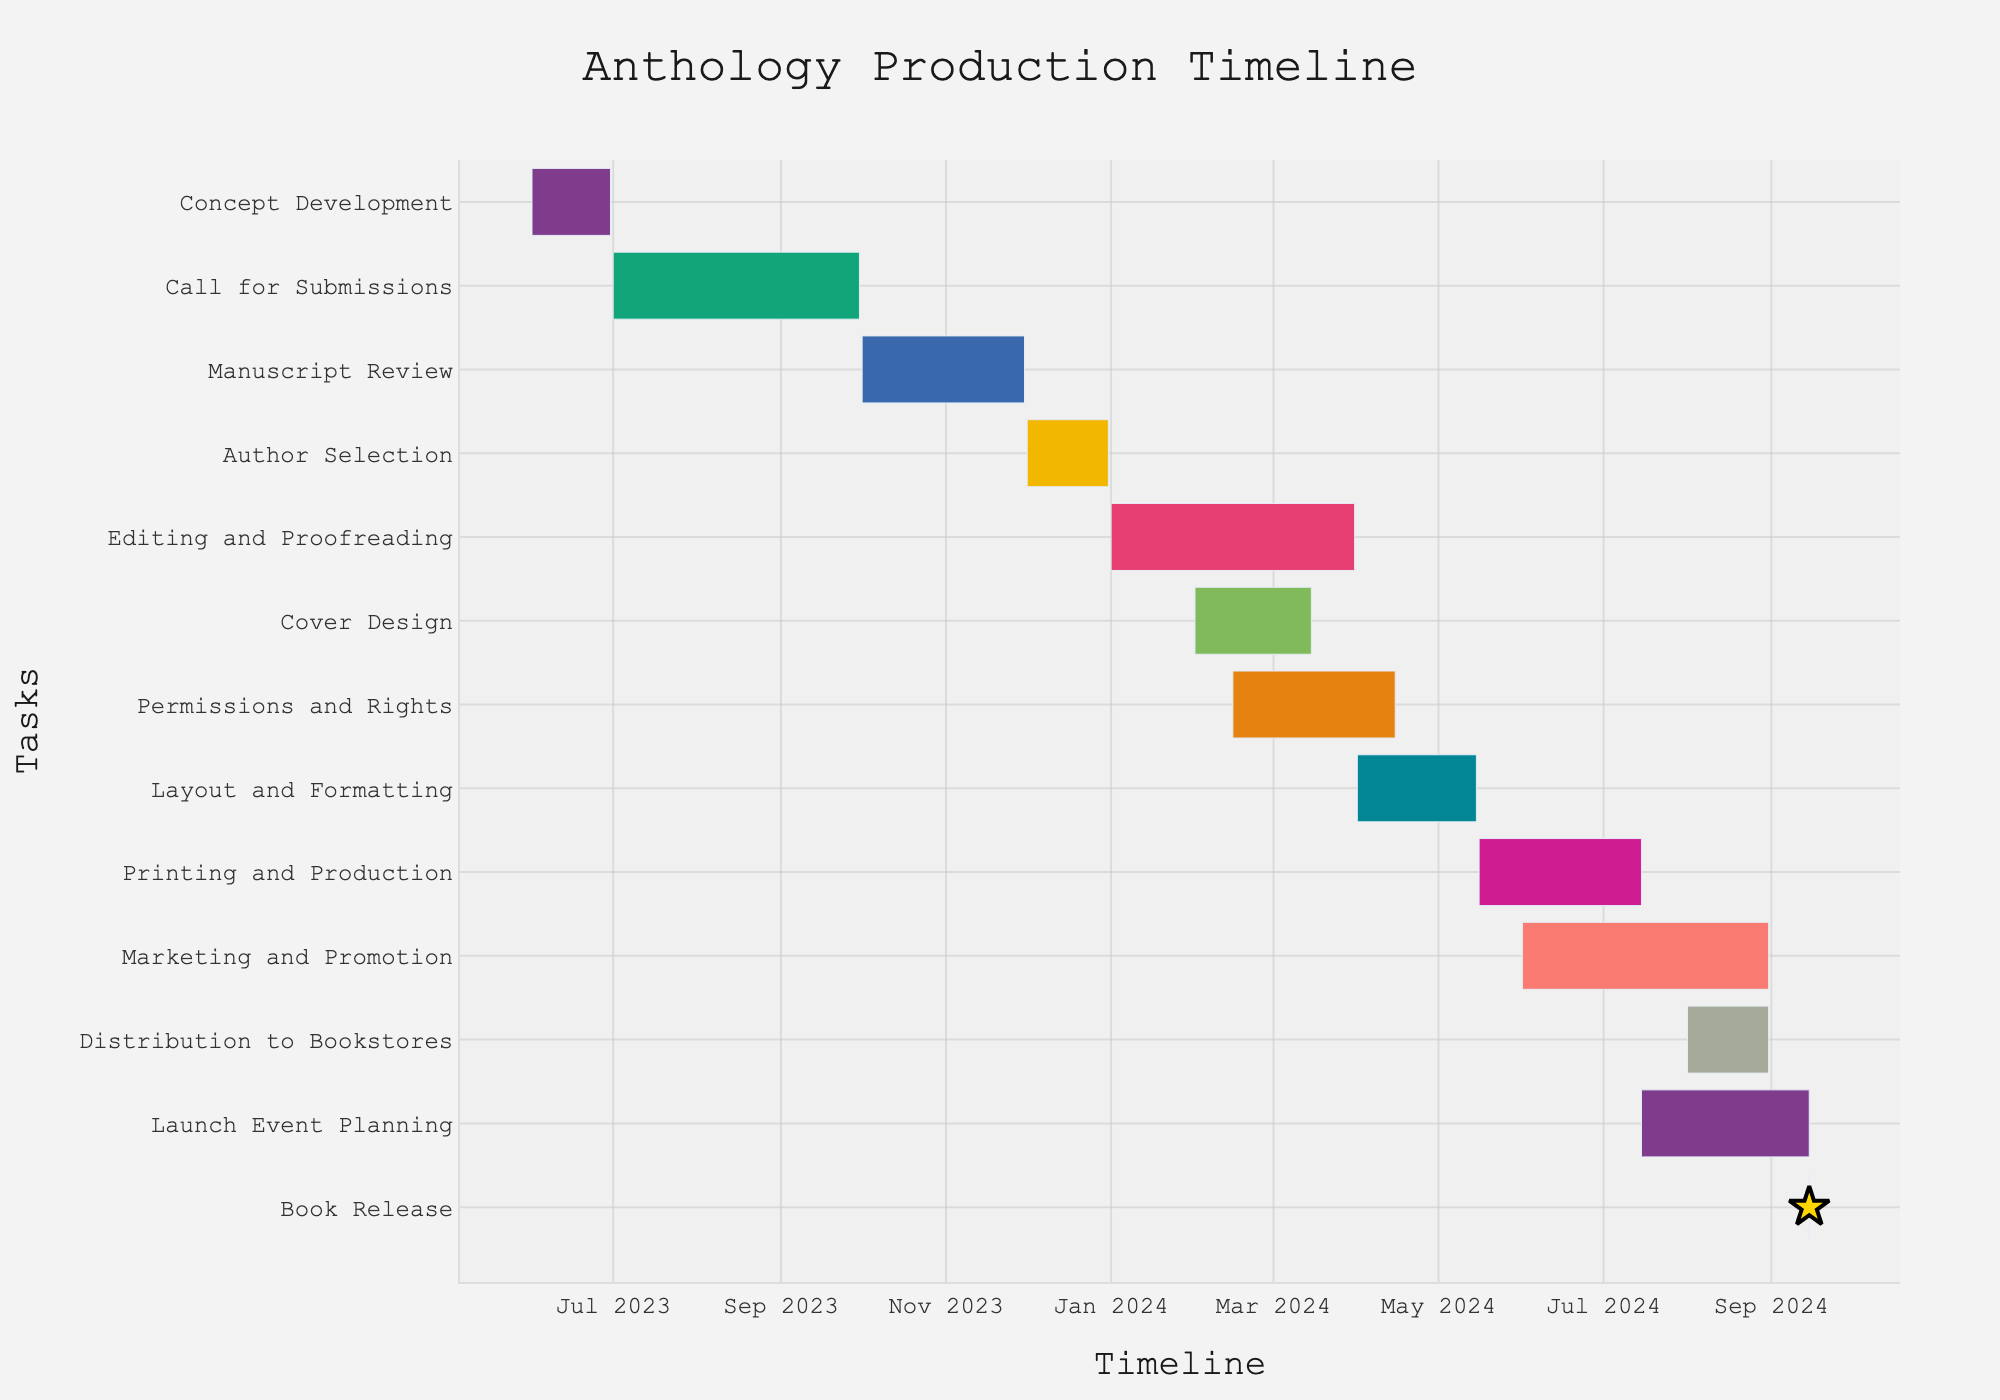How long is the Concept Development phase? The Concept Development phase starts on June 1, 2023, and ends on June 30, 2023. To calculate the duration, count the days from June 1 to June 30, which is 30 days.
Answer: 30 days When does the Call for Submissions start and end? The Call for Submissions starts on July 1, 2023, and ends on September 30, 2023, as shown in the timeline.
Answer: July 1, 2023, to September 30, 2023 Which phase overlaps with both Editing and Proofreading and Cover Design? Permissions and Rights overlaps with both Editing and Proofreading (from February 15, 2024, to April 15, 2024) and Cover Design (from February 1, 2024, to March 15, 2024).
Answer: Permissions and Rights How long does the Layout and Formatting phase last? The Layout and Formatting phase starts on April 1, 2024, and ends on May 15, 2024. To determine the duration, count the days from April 1 to May 15, which is 45 days.
Answer: 45 days What is the shortest phase in the timeline? The shortest phase is the Book Release, which only lasts for one day on September 15, 2024.
Answer: Book Release How many days earlier does the Printing and Production phase end relative to the Marketing and Promotion phase? Printing and Production ends on July 15, 2024, and Marketing and Promotion ends on August 31, 2024. To find the difference, count the days from July 15 to August 31, which is 47 days.
Answer: 47 days Which two phases run concurrently from February 15, 2024? Permissions and Rights and Editing and Proofreading both start on February 15, 2024, and run concurrently.
Answer: Permissions and Rights and Editing and Proofreading What is the total duration from the start of Concept Development to the Book Release? Concept Development starts on June 1, 2023, and Book Release is on September 15, 2024. To find the total duration, calculate the time span between these two dates, which is 472 days.
Answer: 472 days Which phase starts immediately after Manuscript Review ends? Author Selection starts immediately after Manuscript Review ends, with Manuscript Review ending on November 30, 2023, and Author Selection starting on December 1, 2023.
Answer: Author Selection 